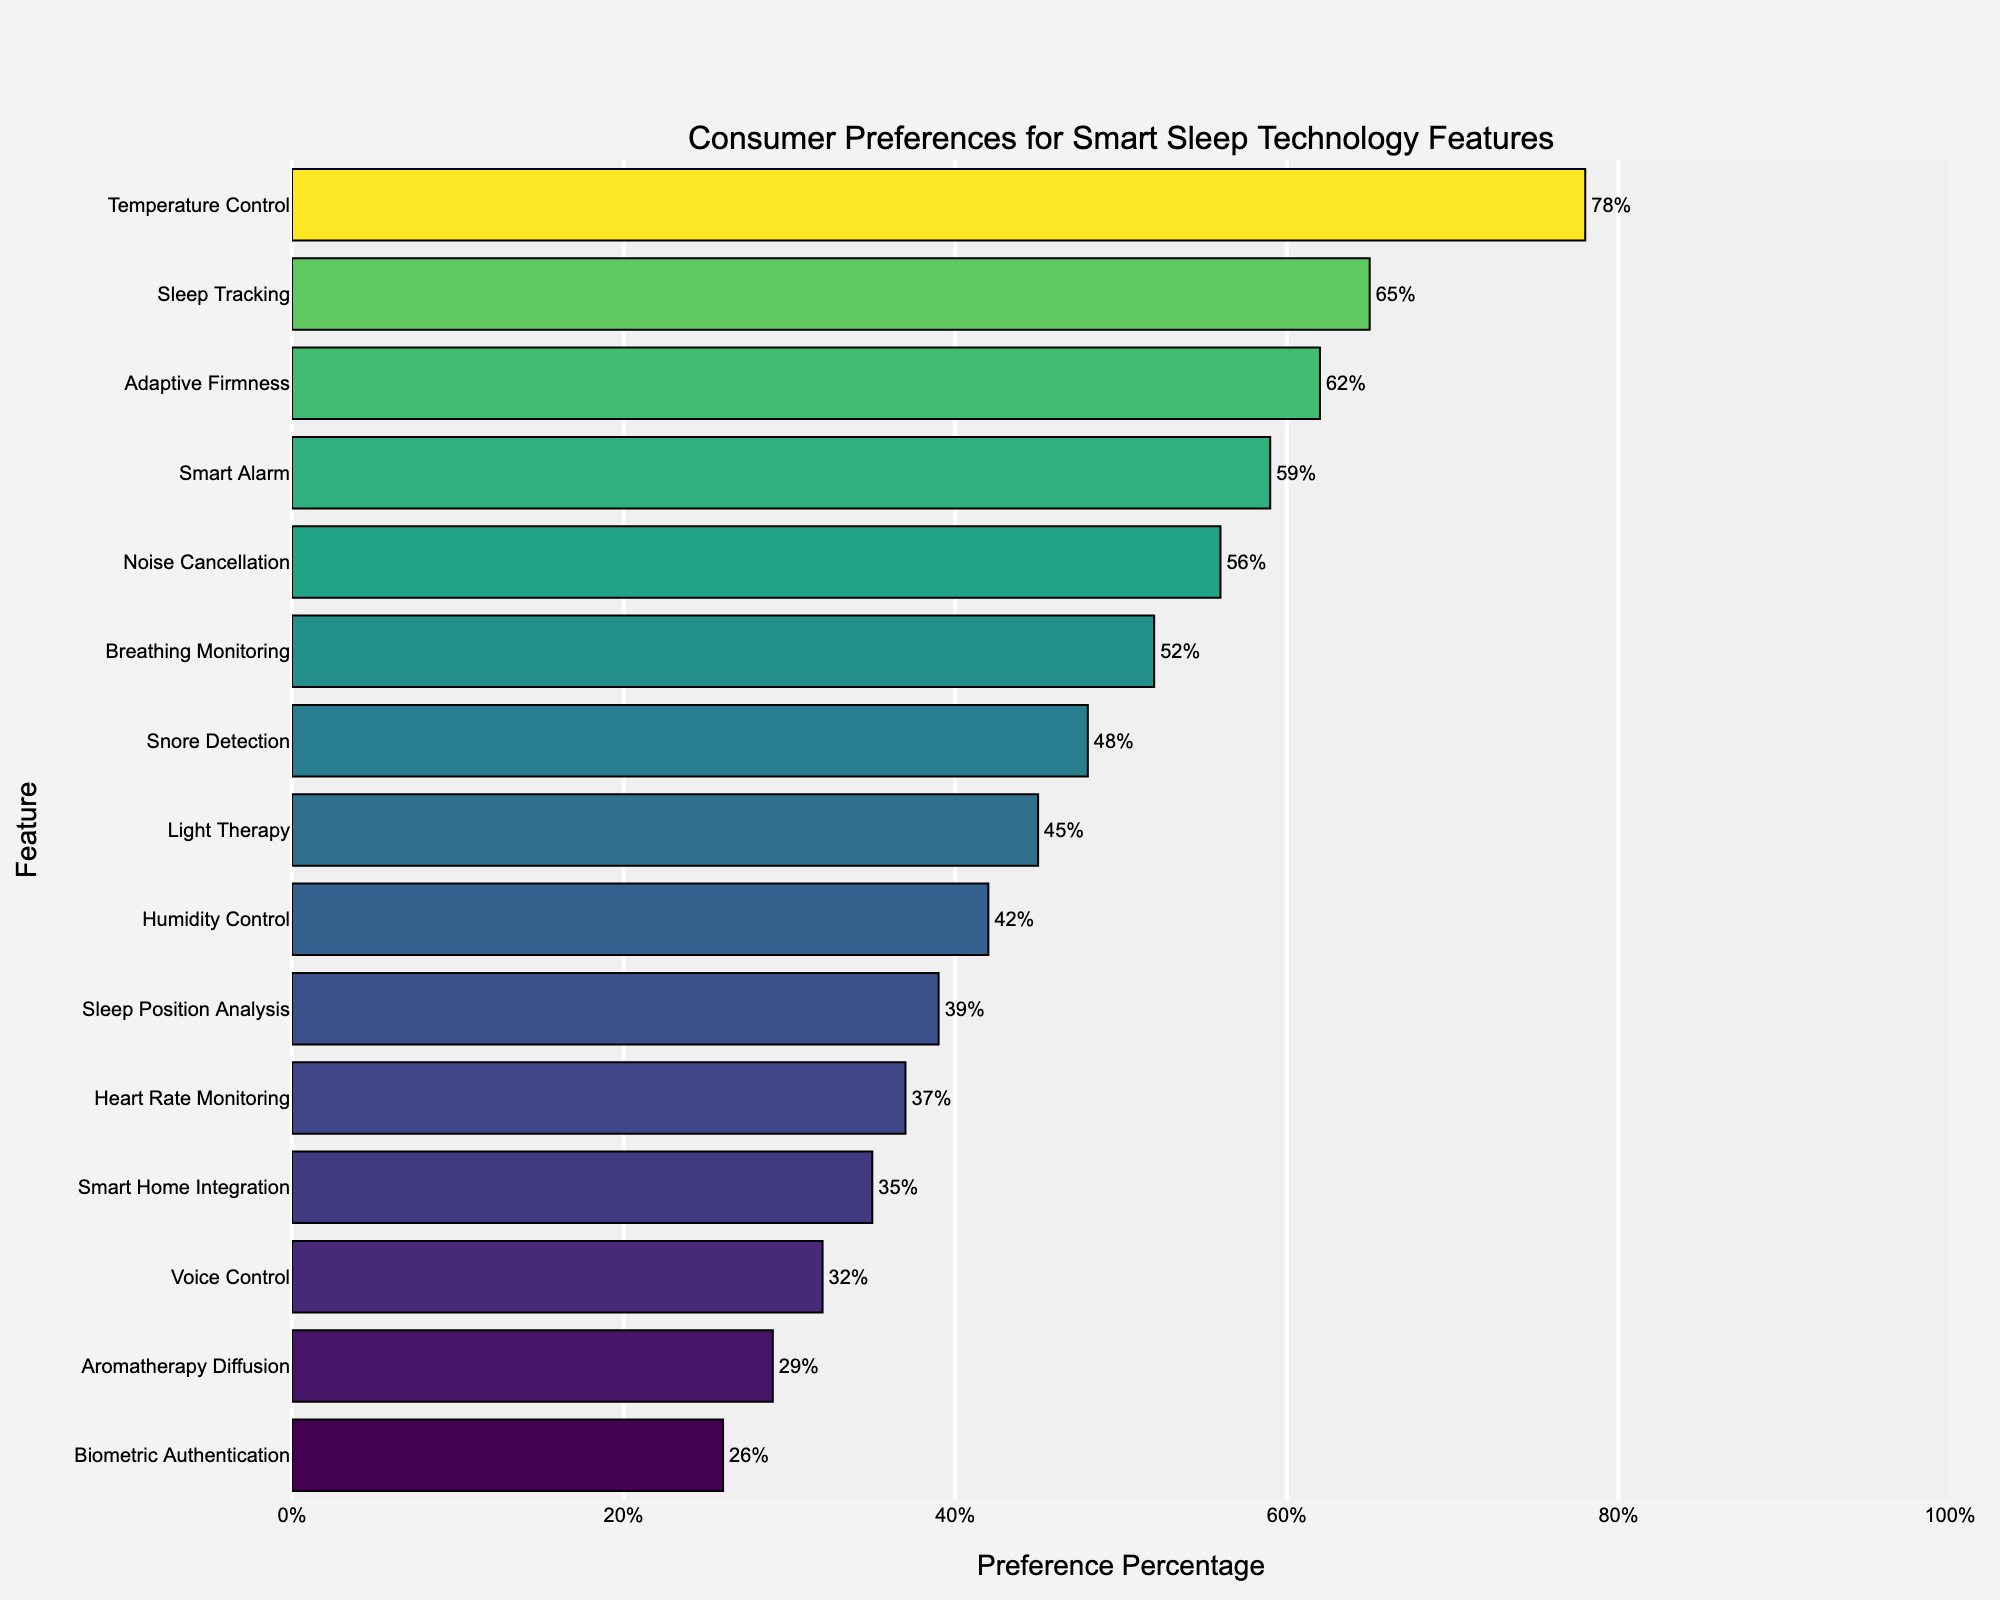Which feature has the highest consumer preference? By looking at the bars, the tallest bar represents the feature with the highest consumer preference. The feature at the top of the chart has the highest value, which is Temperature Control at 78%.
Answer: Temperature Control Which two features have the closest preference percentages? Visually comparing the lengths of the bars, the features with nearly equal heights and close percentages are Adaptive Firmness and Smart Alarm with 62% and 59% respectively.
Answer: Adaptive Firmness and Smart Alarm What is the combined preference percentage of Noise Cancellation and Light Therapy? Adding the preference percentages of Noise Cancellation (56%) and Light Therapy (45%), we get 56 + 45 = 101.
Answer: 101% Which feature has a higher preference: Heart Rate Monitoring or Voice Control? Heart Rate Monitoring is visually higher on the chart than Voice Control, indicating a higher preference. Heart Rate Monitoring is at 37% and Voice Control is at 32%.
Answer: Heart Rate Monitoring What’s the difference in preference percentage between Temperature Control and Snore Detection? Subtract the preference percentage of Snore Detection (48%) from that of Temperature Control (78%). So, 78 - 48 = 30.
Answer: 30% Which feature has the lowest consumer preference? The shortest bar in the chart represents the feature with the lowest consumer preference. The feature with the lowest value is Biometric Authentication at 26%.
Answer: Biometric Authentication How many features have a consumer preference percentage of 50% or more? Counting the bars that extend to 50% or more reveals that there are six features: Temperature Control, Sleep Tracking, Adaptive Firmness, Smart Alarm, Noise Cancellation, and Breathing Monitoring.
Answer: 6 Is the preference for Smart Home Integration higher or lower than Sleep Position Analysis? By comparing the bars visually, Smart Home Integration (35%) is lower than Sleep Position Analysis (39%).
Answer: Lower Which features fall into the middle 50% of consumer preferences range-wise? Sorting the percentages to find the middle 50% range, we focus on features from a sorted list starting after 25% and below 75%. These features are Noise Cancellation, Breathing Monitoring, Snore Detection, Light Therapy, and Humidity Control.
Answer: Noise Cancellation, Breathing Monitoring, Snore Detection, Light Therapy, Humidity Control 